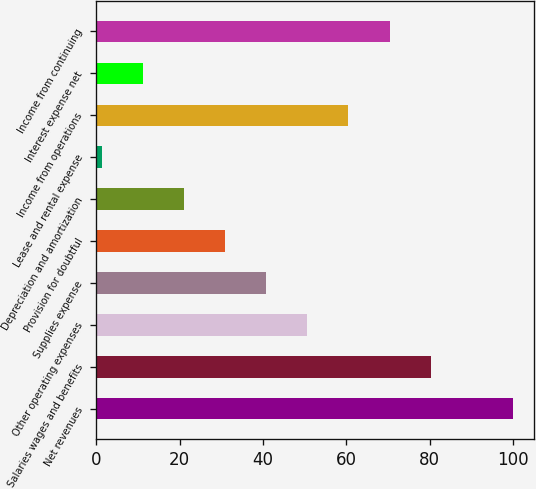Convert chart to OTSL. <chart><loc_0><loc_0><loc_500><loc_500><bar_chart><fcel>Net revenues<fcel>Salaries wages and benefits<fcel>Other operating expenses<fcel>Supplies expense<fcel>Provision for doubtful<fcel>Depreciation and amortization<fcel>Lease and rental expense<fcel>Income from operations<fcel>Interest expense net<fcel>Income from continuing<nl><fcel>100<fcel>80.26<fcel>50.65<fcel>40.78<fcel>30.91<fcel>21.04<fcel>1.3<fcel>60.52<fcel>11.17<fcel>70.39<nl></chart> 